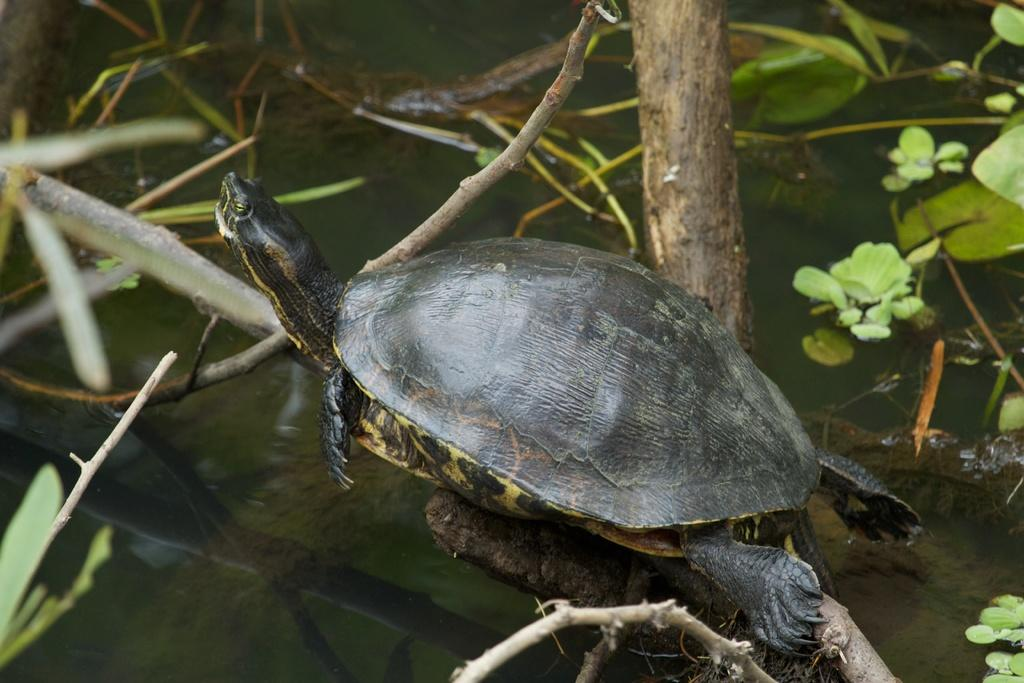What animal is present in the image? There is a turtle in the image. What colors can be seen on the turtle? The turtle is black and yellow in color. Where is the turtle located in the image? The turtle is on the branch of a tree. What can be seen in the background of the image? There is water and plants visible in the background of the image. What type of humor is being displayed by the turtle in the image? There is no humor being displayed by the turtle in the image; it is simply sitting on a tree branch. Can you tell me where the bedroom is located in the image? There is no bedroom present in the image; it features a turtle on a tree branch with a background of water and plants. 